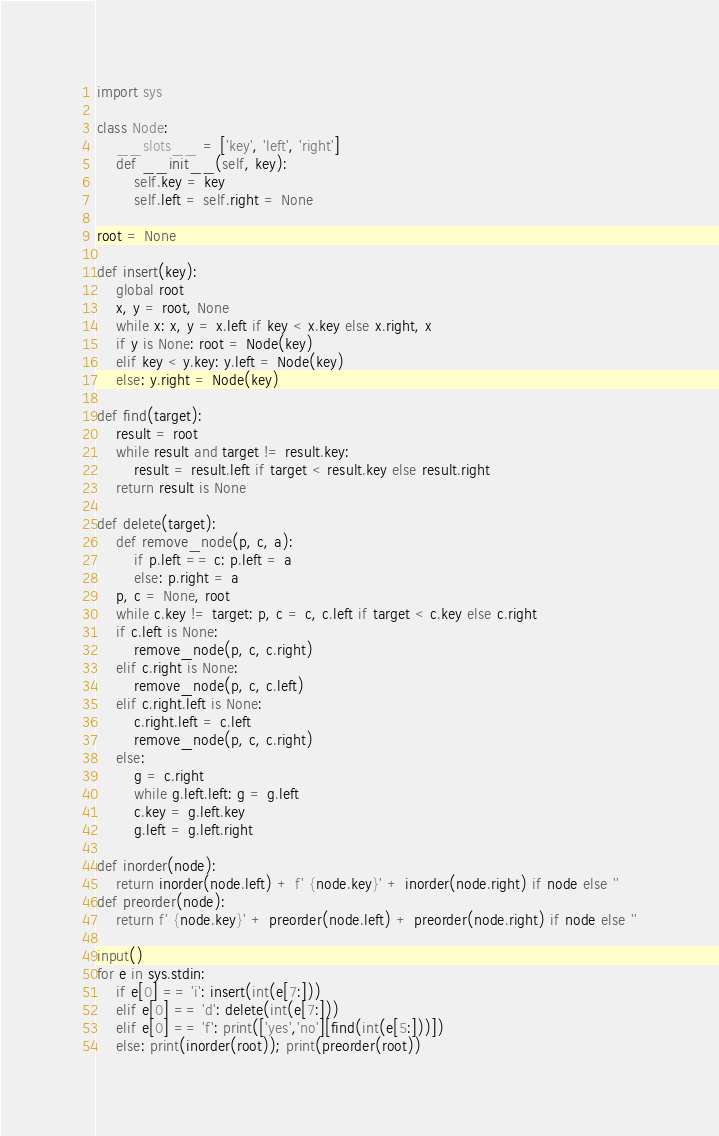<code> <loc_0><loc_0><loc_500><loc_500><_Python_>import sys

class Node:
    __slots__ = ['key', 'left', 'right']
    def __init__(self, key):
        self.key = key
        self.left = self.right = None

root = None

def insert(key):
    global root
    x, y = root, None
    while x: x, y = x.left if key < x.key else x.right, x
    if y is None: root = Node(key)
    elif key < y.key: y.left = Node(key)
    else: y.right = Node(key)

def find(target):
    result = root
    while result and target != result.key:
        result = result.left if target < result.key else result.right
    return result is None

def delete(target):
    def remove_node(p, c, a):
        if p.left == c: p.left = a
        else: p.right = a
    p, c = None, root
    while c.key != target: p, c = c, c.left if target < c.key else c.right
    if c.left is None:
        remove_node(p, c, c.right)
    elif c.right is None:
        remove_node(p, c, c.left)
    elif c.right.left is None:
        c.right.left = c.left
        remove_node(p, c, c.right)
    else:
        g = c.right
        while g.left.left: g = g.left
        c.key = g.left.key
        g.left = g.left.right

def inorder(node):
    return inorder(node.left) + f' {node.key}' + inorder(node.right) if node else ''
def preorder(node):
    return f' {node.key}' + preorder(node.left) + preorder(node.right) if node else ''

input()
for e in sys.stdin:
    if e[0] == 'i': insert(int(e[7:]))
    elif e[0] == 'd': delete(int(e[7:]))
    elif e[0] == 'f': print(['yes','no'][find(int(e[5:]))])
    else: print(inorder(root)); print(preorder(root))
</code> 